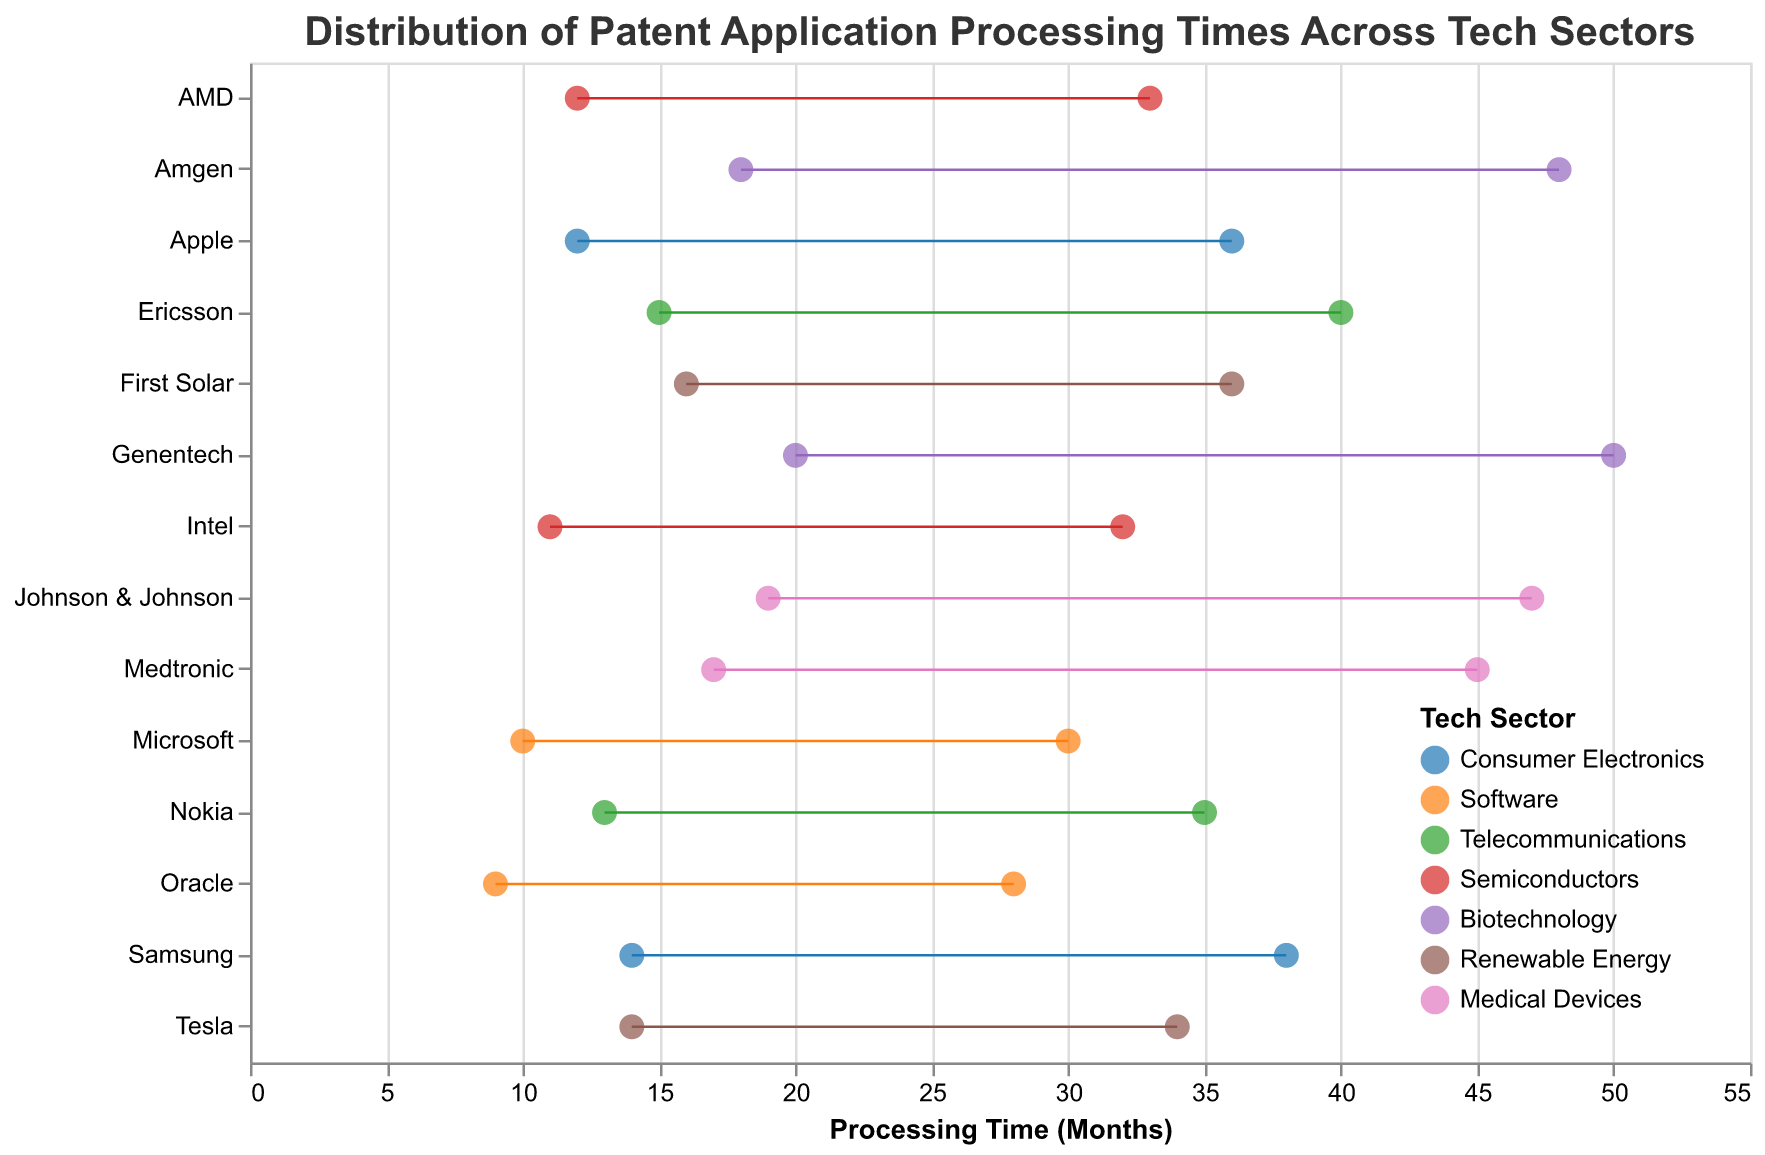What is the title of the figure? The title of the figure is displayed at the top in large font, generally describing what the figure is about.
Answer: Distribution of Patent Application Processing Times Across Tech Sectors Which sector has the longest maximum processing time? The color legend at the bottom-right helps identify sectors by color, and the longest range is identified by the top end of the longest horizontal line, which falls in the "Biotechnology" sector.
Answer: Biotechnology What’s the range of processing times for Amgen? Amgen is located on the vertical axis, and the horizontal line representing it spans from Min Time of 18 months to Max Time of 48 months.
Answer: 18-48 months Which company in the Software sector has the shorter minimum processing time? The companies are listed under the "Software" sector in the legend, and by comparing visually, Oracle has the shorter minimum processing time.
Answer: Oracle How does the maximum processing time of Medtronic compare to that of Amgen? Medtronic in the Medical Devices sector has a maximum processing time of 45 months, while Amgen in the Biotechnology sector has a maximum processing time of 48 months. Medtronic's maximum is 3 months less than Amgen's.
Answer: 3 months less What is the minimum processing time for the company with the shortest minimum time in the Telecommunications sector? The companies under the Telecommunications sector are checked and Nokia has the shortest minimum processing time of 13 months.
Answer: 13 months Which sector has the widest range in processing times? The widest range is characterized by the greatest difference between Min and Max times. Genentech in the Biotechnology sector has the widest range from 20 to 50 months, 30 months span.
Answer: Biotechnology What is the difference in the maximum processing times between Intel and AMD? Both are in the Semiconductors sector. Intel has a maximum of 32 months and AMD has a maximum of 33 months, so the difference is 1 month.
Answer: 1 month Which company has the shortest maximum processing time? Scanning for the shortest horizontal blue point on the right, Oracle has the shortest maximum processing time of 28 months.
Answer: Oracle Which sector has the smallest average minimum processing time? To calculate, we identify Consumer Electronics, Software, Telecommunications, Semiconductors, etc., and determine min times for each company. Software sector’s companies have the minimums of 10 and 9 months, averaging (10+9)/2 = 9.5 months.
Answer: Software 